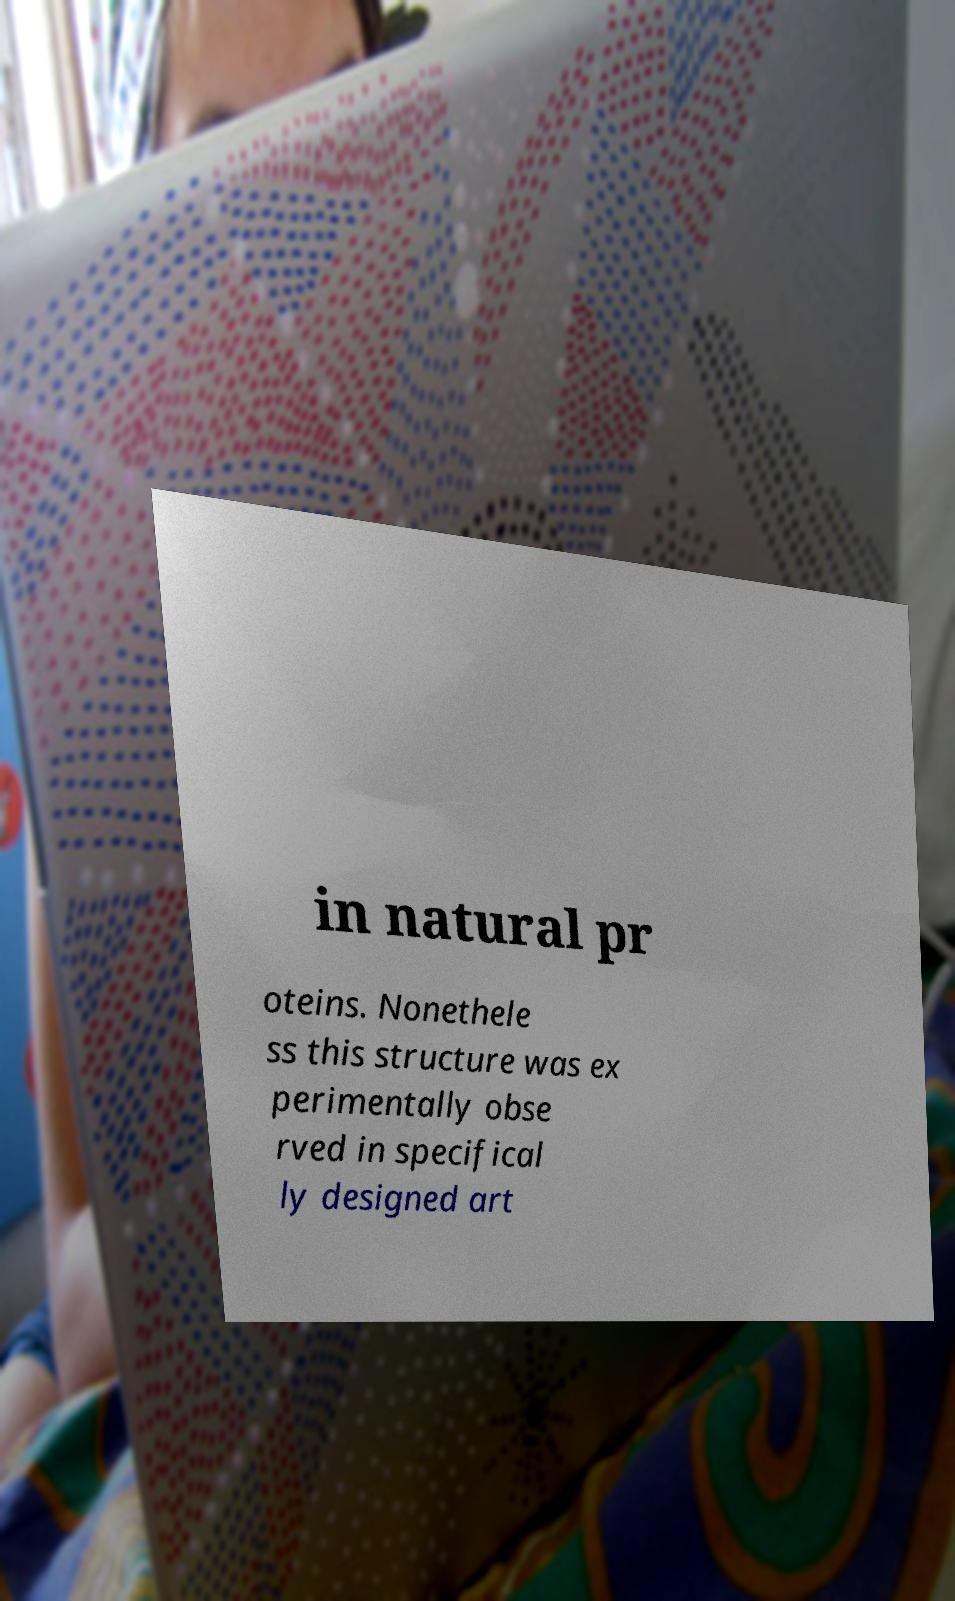Please read and relay the text visible in this image. What does it say? in natural pr oteins. Nonethele ss this structure was ex perimentally obse rved in specifical ly designed art 